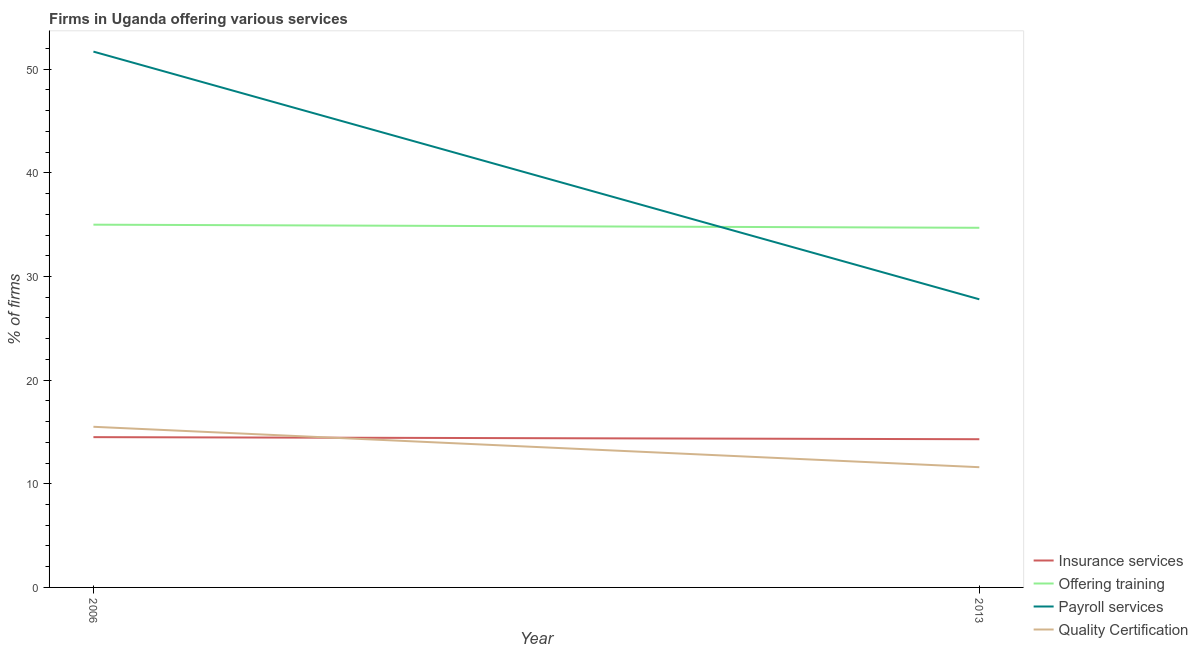How many different coloured lines are there?
Give a very brief answer. 4. Does the line corresponding to percentage of firms offering payroll services intersect with the line corresponding to percentage of firms offering training?
Your answer should be compact. Yes. What is the percentage of firms offering payroll services in 2006?
Ensure brevity in your answer.  51.7. Across all years, what is the maximum percentage of firms offering training?
Offer a terse response. 35. In which year was the percentage of firms offering payroll services minimum?
Make the answer very short. 2013. What is the total percentage of firms offering training in the graph?
Provide a short and direct response. 69.7. What is the difference between the percentage of firms offering insurance services in 2006 and that in 2013?
Keep it short and to the point. 0.2. What is the difference between the percentage of firms offering payroll services in 2006 and the percentage of firms offering insurance services in 2013?
Provide a short and direct response. 37.4. What is the average percentage of firms offering training per year?
Your response must be concise. 34.85. In the year 2013, what is the difference between the percentage of firms offering training and percentage of firms offering payroll services?
Your answer should be very brief. 6.9. In how many years, is the percentage of firms offering training greater than 10 %?
Your answer should be compact. 2. What is the ratio of the percentage of firms offering payroll services in 2006 to that in 2013?
Give a very brief answer. 1.86. Is the percentage of firms offering payroll services in 2006 less than that in 2013?
Offer a very short reply. No. Are the values on the major ticks of Y-axis written in scientific E-notation?
Provide a short and direct response. No. Does the graph contain grids?
Your response must be concise. No. How are the legend labels stacked?
Your response must be concise. Vertical. What is the title of the graph?
Ensure brevity in your answer.  Firms in Uganda offering various services . What is the label or title of the X-axis?
Offer a terse response. Year. What is the label or title of the Y-axis?
Your answer should be very brief. % of firms. What is the % of firms in Payroll services in 2006?
Your answer should be very brief. 51.7. What is the % of firms of Offering training in 2013?
Ensure brevity in your answer.  34.7. What is the % of firms in Payroll services in 2013?
Offer a terse response. 27.8. What is the % of firms of Quality Certification in 2013?
Your answer should be very brief. 11.6. Across all years, what is the maximum % of firms of Insurance services?
Provide a short and direct response. 14.5. Across all years, what is the maximum % of firms in Payroll services?
Keep it short and to the point. 51.7. Across all years, what is the maximum % of firms of Quality Certification?
Ensure brevity in your answer.  15.5. Across all years, what is the minimum % of firms in Insurance services?
Your answer should be very brief. 14.3. Across all years, what is the minimum % of firms of Offering training?
Ensure brevity in your answer.  34.7. Across all years, what is the minimum % of firms in Payroll services?
Offer a terse response. 27.8. What is the total % of firms of Insurance services in the graph?
Offer a very short reply. 28.8. What is the total % of firms in Offering training in the graph?
Give a very brief answer. 69.7. What is the total % of firms of Payroll services in the graph?
Your answer should be compact. 79.5. What is the total % of firms in Quality Certification in the graph?
Your answer should be very brief. 27.1. What is the difference between the % of firms of Insurance services in 2006 and that in 2013?
Offer a terse response. 0.2. What is the difference between the % of firms of Payroll services in 2006 and that in 2013?
Your answer should be very brief. 23.9. What is the difference between the % of firms in Insurance services in 2006 and the % of firms in Offering training in 2013?
Your answer should be very brief. -20.2. What is the difference between the % of firms in Offering training in 2006 and the % of firms in Payroll services in 2013?
Your answer should be compact. 7.2. What is the difference between the % of firms of Offering training in 2006 and the % of firms of Quality Certification in 2013?
Ensure brevity in your answer.  23.4. What is the difference between the % of firms in Payroll services in 2006 and the % of firms in Quality Certification in 2013?
Your answer should be very brief. 40.1. What is the average % of firms of Offering training per year?
Provide a short and direct response. 34.85. What is the average % of firms in Payroll services per year?
Provide a short and direct response. 39.75. What is the average % of firms of Quality Certification per year?
Provide a succinct answer. 13.55. In the year 2006, what is the difference between the % of firms of Insurance services and % of firms of Offering training?
Your response must be concise. -20.5. In the year 2006, what is the difference between the % of firms of Insurance services and % of firms of Payroll services?
Make the answer very short. -37.2. In the year 2006, what is the difference between the % of firms in Insurance services and % of firms in Quality Certification?
Provide a succinct answer. -1. In the year 2006, what is the difference between the % of firms of Offering training and % of firms of Payroll services?
Provide a short and direct response. -16.7. In the year 2006, what is the difference between the % of firms of Offering training and % of firms of Quality Certification?
Your answer should be compact. 19.5. In the year 2006, what is the difference between the % of firms of Payroll services and % of firms of Quality Certification?
Ensure brevity in your answer.  36.2. In the year 2013, what is the difference between the % of firms of Insurance services and % of firms of Offering training?
Your answer should be very brief. -20.4. In the year 2013, what is the difference between the % of firms in Offering training and % of firms in Payroll services?
Ensure brevity in your answer.  6.9. In the year 2013, what is the difference between the % of firms in Offering training and % of firms in Quality Certification?
Offer a terse response. 23.1. In the year 2013, what is the difference between the % of firms in Payroll services and % of firms in Quality Certification?
Provide a succinct answer. 16.2. What is the ratio of the % of firms of Insurance services in 2006 to that in 2013?
Provide a succinct answer. 1.01. What is the ratio of the % of firms in Offering training in 2006 to that in 2013?
Your answer should be compact. 1.01. What is the ratio of the % of firms of Payroll services in 2006 to that in 2013?
Your answer should be compact. 1.86. What is the ratio of the % of firms in Quality Certification in 2006 to that in 2013?
Ensure brevity in your answer.  1.34. What is the difference between the highest and the second highest % of firms of Insurance services?
Your answer should be compact. 0.2. What is the difference between the highest and the second highest % of firms of Payroll services?
Provide a short and direct response. 23.9. What is the difference between the highest and the lowest % of firms in Payroll services?
Provide a short and direct response. 23.9. 